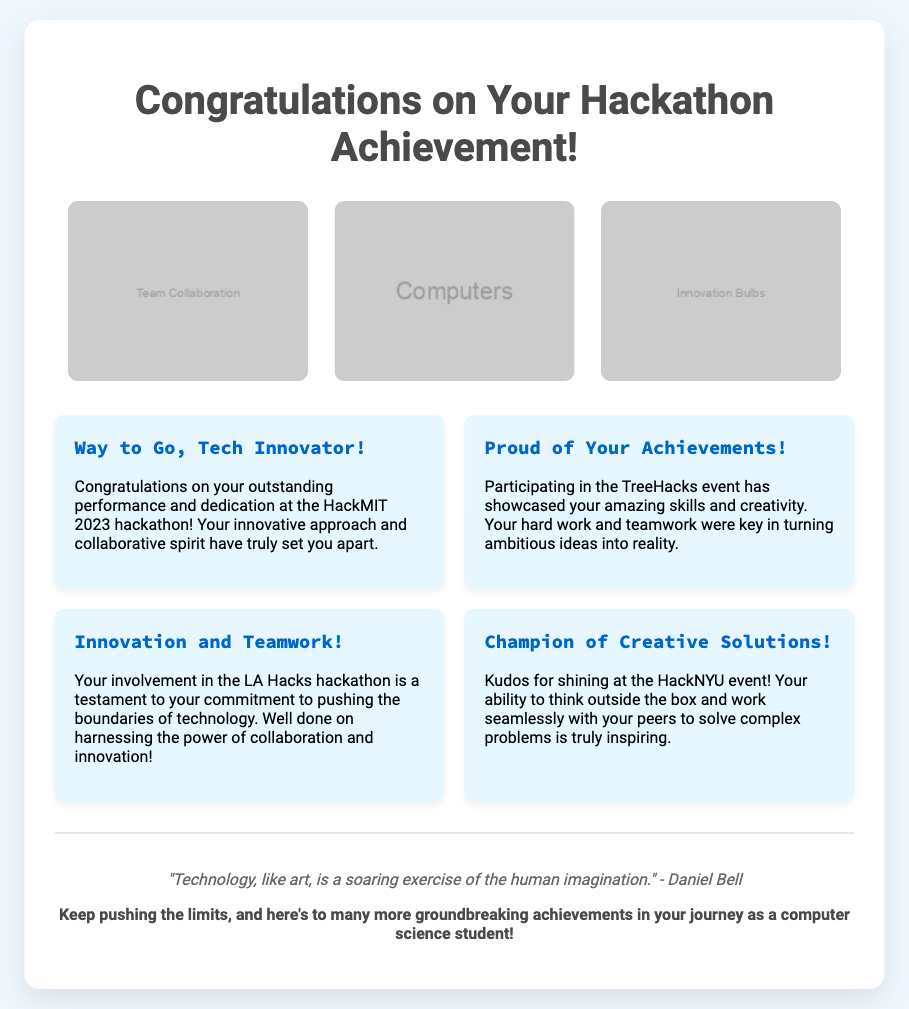What is the title of the card? The title of the card is prominently displayed at the top, stating the purpose of the greeting card.
Answer: Congratulations on Your Hackathon Achievement! How many illustrations are there? There are three illustrations represented in the card that highlight themes related to the hackathon.
Answer: 3 Which event is mentioned in the first message? The first message congratulates participation specifically at a recognized hackathon event.
Answer: HackMIT 2023 What is the quote attributed to? The quote included in the footer is from a notable individual known for insights on technology and art, adding a reflective touch to the card.
Answer: Daniel Bell What is the background color of the card? The background color is specified in the style section of the document, giving the card a light and welcoming appearance.
Answer: #f0f8ff What does the last message encourage? The last message embodies motivational advice related to the recipient's continuous journey in technology and innovation.
Answer: Keep pushing the limits What is the design style of the card? The overall design style of the card combines aesthetics that reflect a combination of technology, creativity, and celebration.
Answer: Tech-themed 